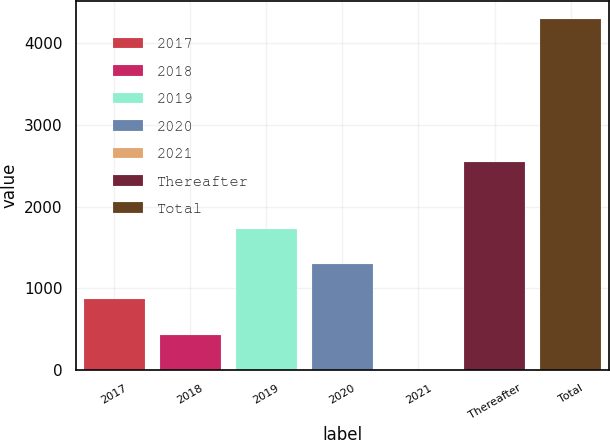Convert chart to OTSL. <chart><loc_0><loc_0><loc_500><loc_500><bar_chart><fcel>2017<fcel>2018<fcel>2019<fcel>2020<fcel>2021<fcel>Thereafter<fcel>Total<nl><fcel>860.72<fcel>430.41<fcel>1721.34<fcel>1291.03<fcel>0.1<fcel>2546.1<fcel>4303.2<nl></chart> 